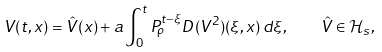<formula> <loc_0><loc_0><loc_500><loc_500>V ( t , x ) = \hat { V } ( x ) + a \int _ { 0 } ^ { t } P _ { \rho } ^ { t - \xi } D ( V ^ { 2 } ) ( \xi , x ) \, d \xi , \quad \hat { V } \in \mathcal { H } _ { s } ,</formula> 